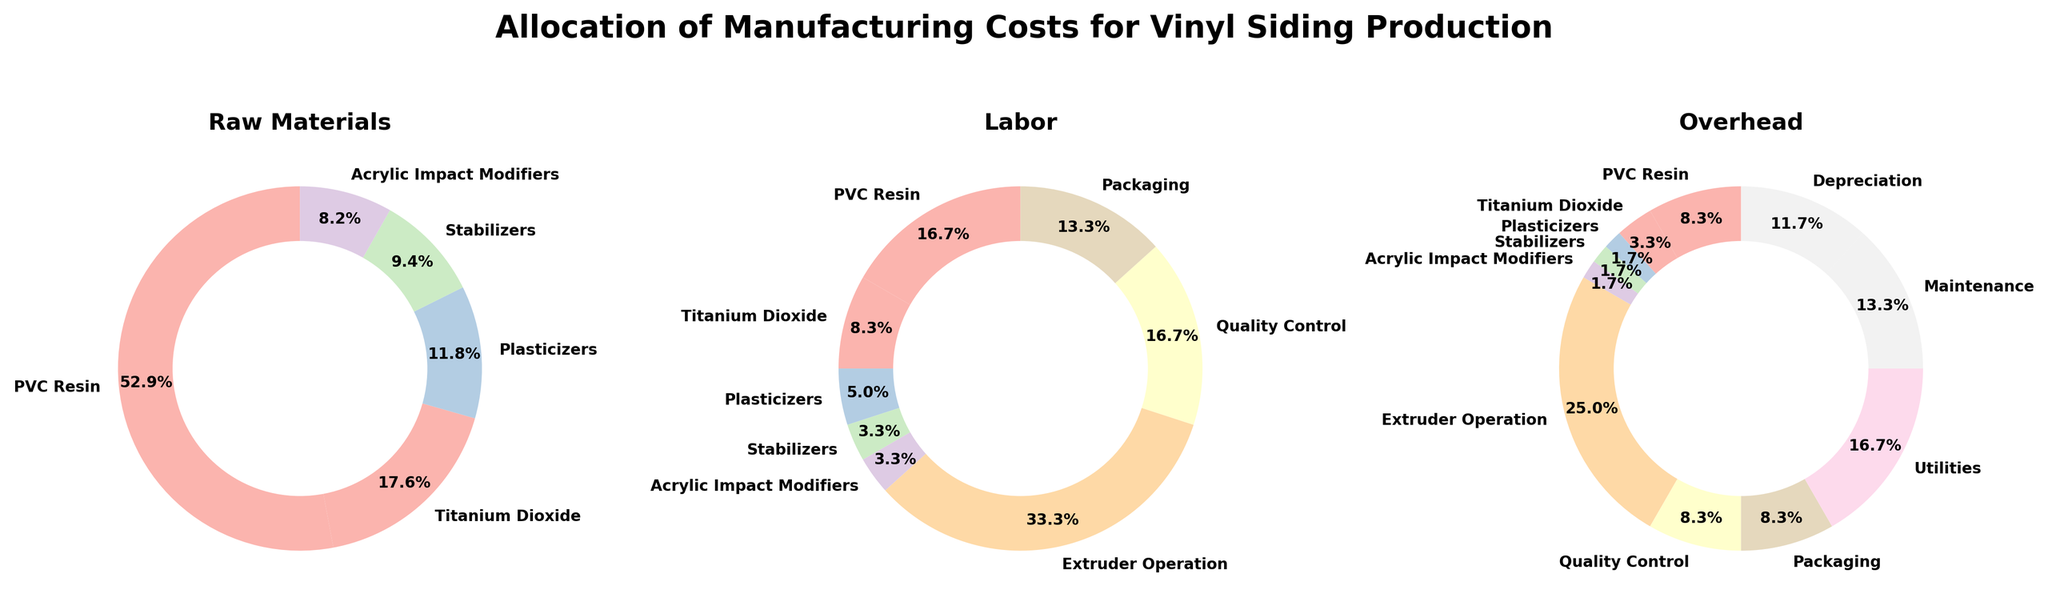What is the title of the figure? The title of the figure is displayed at the top center of the entire plot. It reads, "Allocation of Manufacturing Costs for Vinyl Siding Production".
Answer: Allocation of Manufacturing Costs for Vinyl Siding Production Which category has the largest proportion in the 'Raw Materials' pie chart? The 'Raw Materials' pie chart shows the proportions of different categories. PVC Resin has the largest slice, indicating the highest percentage.
Answer: PVC Resin What percentage of the 'Labor' pie chart is allocated to Extruder Operation? In the 'Labor' pie chart, the slice labeled "Extruder Operation" accounts for 20%, as shown by its label.
Answer: 20% How many categories are present in the 'Overhead' pie chart? By counting the segments in the 'Overhead' pie chart, we can see that there are five categories.
Answer: 5 Which cost component has a higher percentage in the 'Overhead' category, Utilities or Depreciation? Comparing the slices labeled "Utilities" and "Depreciation" in the 'Overhead' chart shows that Utilities (10%) has a higher percentage than Depreciation (7%).
Answer: Utilities What is the combined percentage of Titanium Dioxide in 'Raw Materials' and 'Labor'? By looking at 'Raw Materials' and 'Labor' pie charts, Titanium Dioxide occupies 15% in 'Raw Materials' and 5% in 'Labor'. Adding these together gives 20%.
Answer: 20% How does the proportion of costs allocated to Packaging differ between 'Labor' and 'Overhead'? In the 'Labor' pie chart, Packaging accounts for 8%, while in the 'Overhead' pie chart, it takes 5%. The difference is 8% - 5% = 3%.
Answer: 3% Which categories are only present in the 'Overhead' pie chart and not in the other two categories? By cross-referencing all three pie charts, Maintenance and Depreciation are found only in the 'Overhead' pie chart.
Answer: Maintenance and Depreciation What is the total percentage allocated to all the categories in 'Raw Materials'? Summing the percentages for all categories in the 'Raw Materials' pie chart (45% + 15% + 10% + 8% + 7%) equals 85%.
Answer: 85% Which has more categories with at least 10% allocation, the 'Labor' or the 'Raw Materials' pie chart? The 'Labor' pie chart has one category with at least 10% allocation (Extruder Operation), while 'Raw Materials' has three categories (PVC Resin, Titanium Dioxide, and Plasticizers). Thus, 'Raw Materials' has more categories with at least 10% allocation.
Answer: Raw Materials 